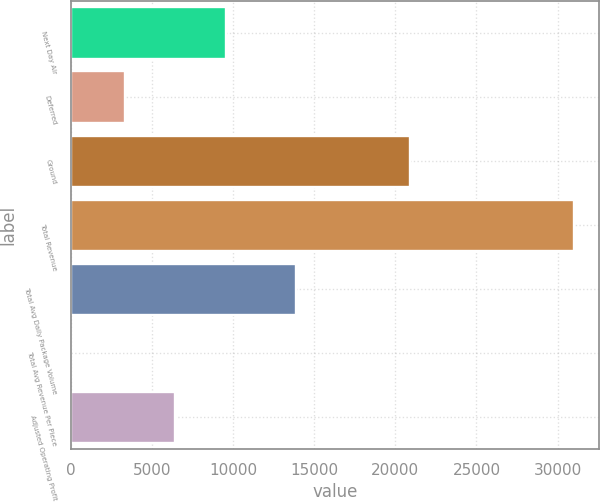Convert chart to OTSL. <chart><loc_0><loc_0><loc_500><loc_500><bar_chart><fcel>Next Day Air<fcel>Deferred<fcel>Ground<fcel>Total Revenue<fcel>Total Avg Daily Package Volume<fcel>Total Avg Revenue Per Piece<fcel>Adjusted Operating Profit<nl><fcel>9554.22<fcel>3359<fcel>20888<fcel>30985<fcel>13857<fcel>8.87<fcel>6456.61<nl></chart> 